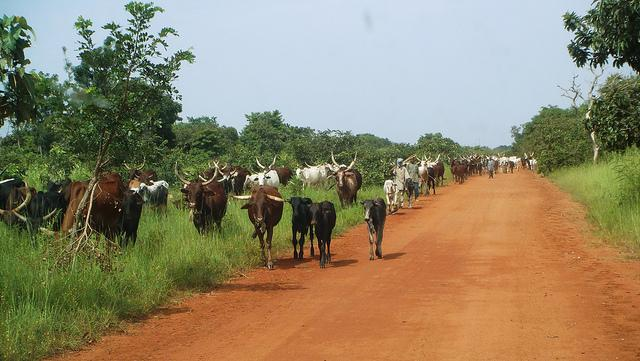What is on the dirt road? cows 